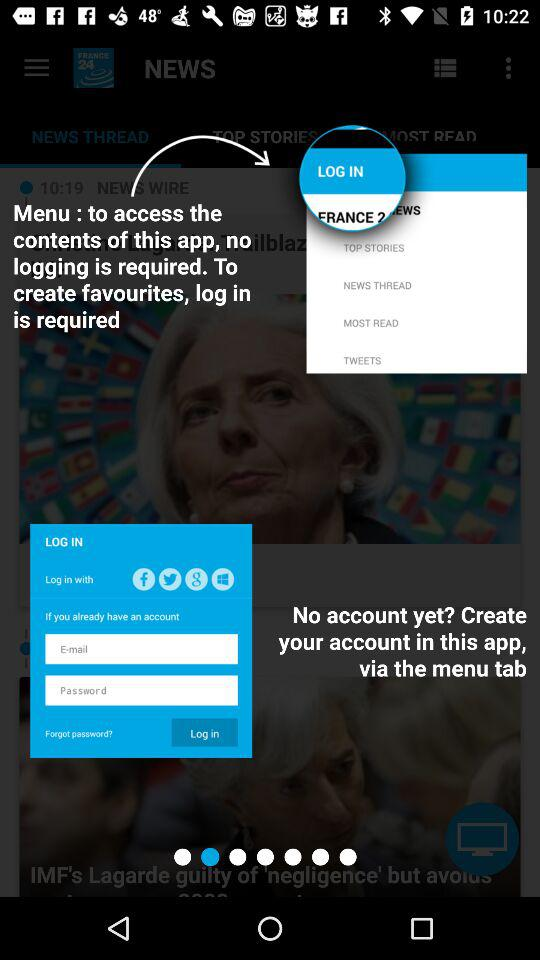How many text fields are there on the screen?
Answer the question using a single word or phrase. 2 